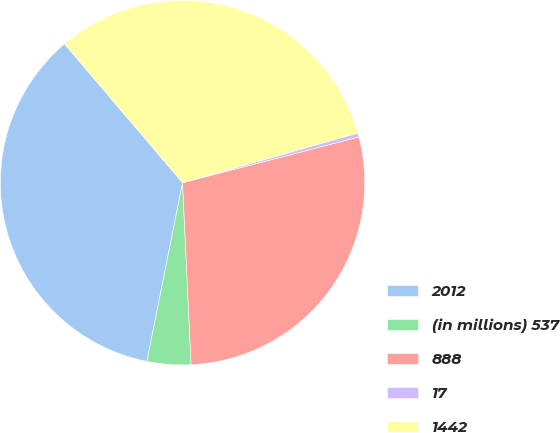Convert chart to OTSL. <chart><loc_0><loc_0><loc_500><loc_500><pie_chart><fcel>2012<fcel>(in millions) 537<fcel>888<fcel>17<fcel>1442<nl><fcel>35.65%<fcel>3.88%<fcel>28.29%<fcel>0.35%<fcel>31.82%<nl></chart> 